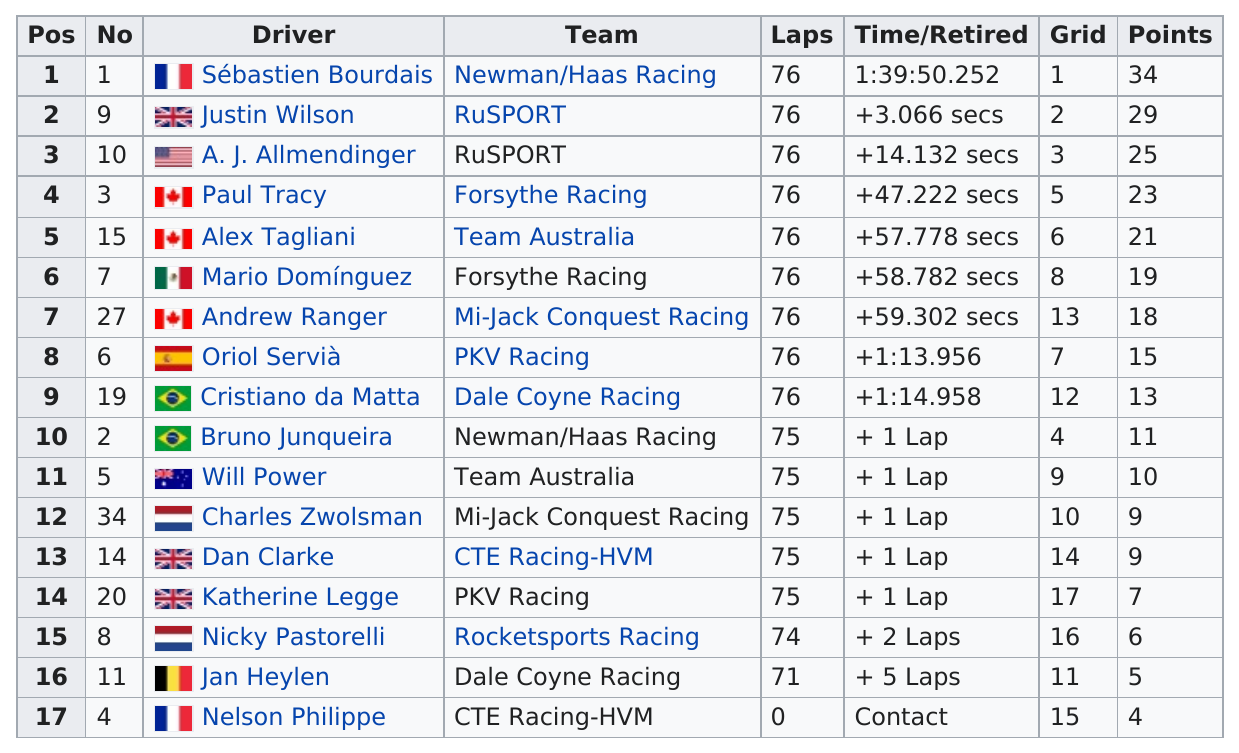Mention a couple of crucial points in this snapshot. Charles Zwolsman earned the same number of points as Dan Clarke. Sebastien Bourdais earned the most points among drivers. The driver who received the most points is separated from the driver who received the least points by a total of 30 points. This text indicates that 10 countries are represented. Nelson Philippe, the driver, earned the least amount of points. 